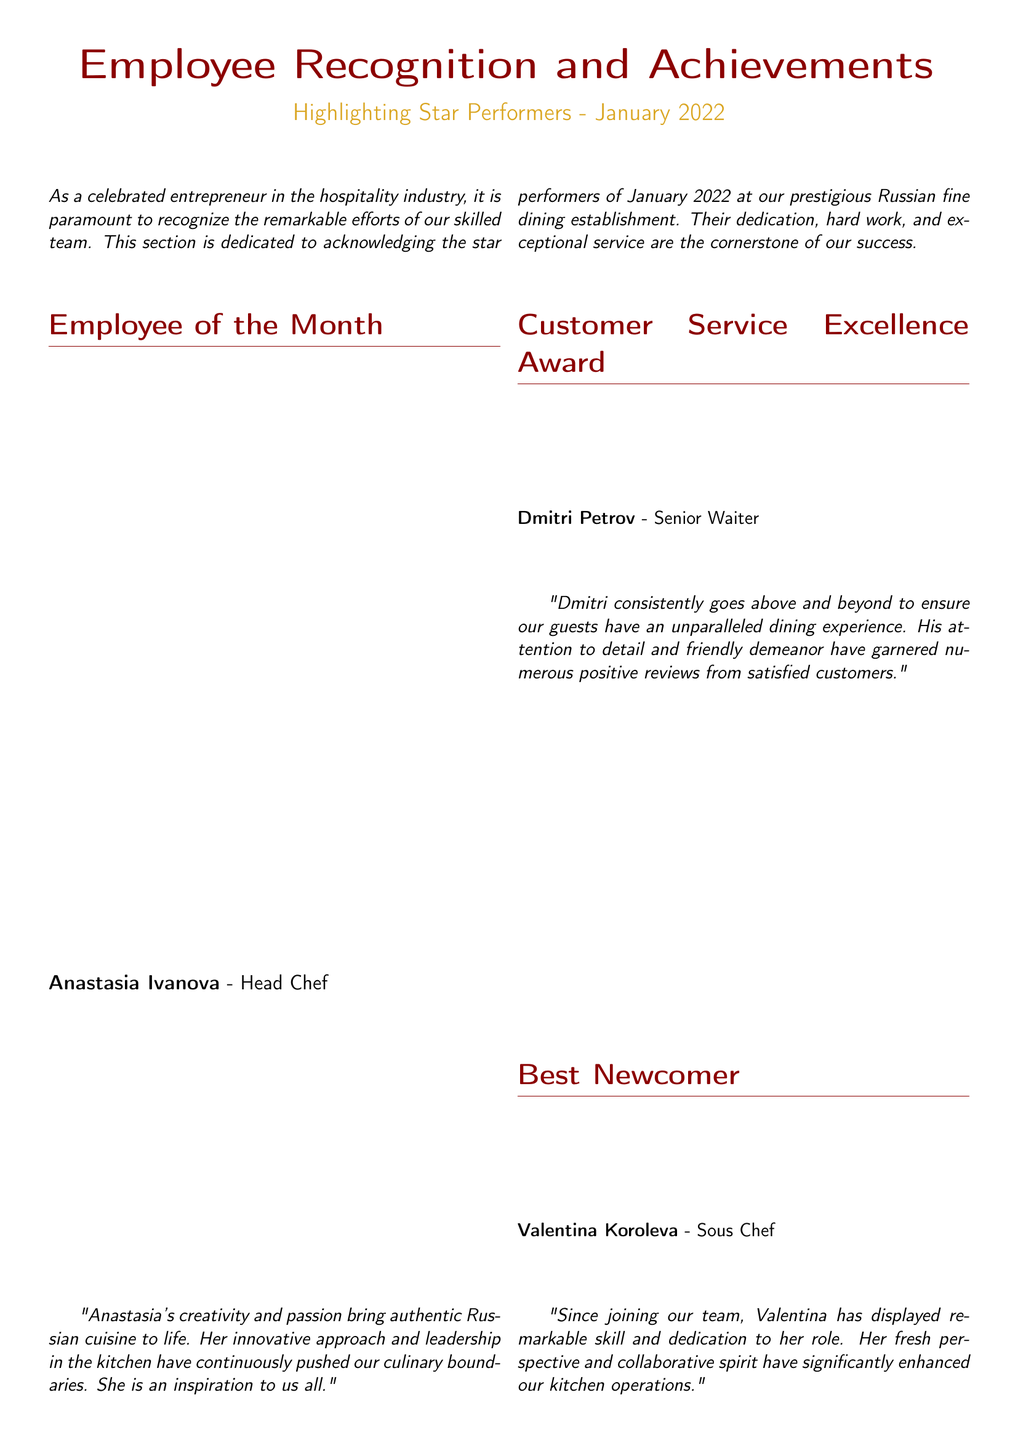What is the title of the document? The title of the document, which is highlighted at the beginning, is "Employee Recognition and Achievements."
Answer: Employee Recognition and Achievements Who is the Employee of the Month? The document specifically states that Anastasia Ivanova is recognized as the Employee of the Month.
Answer: Anastasia Ivanova What award did Dmitri Petrov receive? The document mentions that Dmitri Petrov received the Customer Service Excellence Award.
Answer: Customer Service Excellence Award What position does Valentina Koroleva hold? Valentina Koroleva is identified in the document as the Sous Chef.
Answer: Sous Chef How many star performers are highlighted in January 2022? The document lists four specific star performers recognized during January 2022.
Answer: Four Which award did Sergei Novikov receive? The document notes that Sergei Novikov was honored with the Outstanding Commitment Award.
Answer: Outstanding Commitment Award What trait is highlighted for Anastasia Ivanova in her testimonial? The testimonial for Anastasia Ivanova emphasizes her creativity and passion in bringing authentic Russian cuisine to life.
Answer: Creativity and passion What is the overarching theme of the document? The document focuses on acknowledging and celebrating the achievements of employees at the Russian fine dining establishment.
Answer: Acknowledging and celebrating achievements Which color is used for the section titles in the document? The section titles are colored using dark red, as indicated in the document's design choices.
Answer: Dark red 